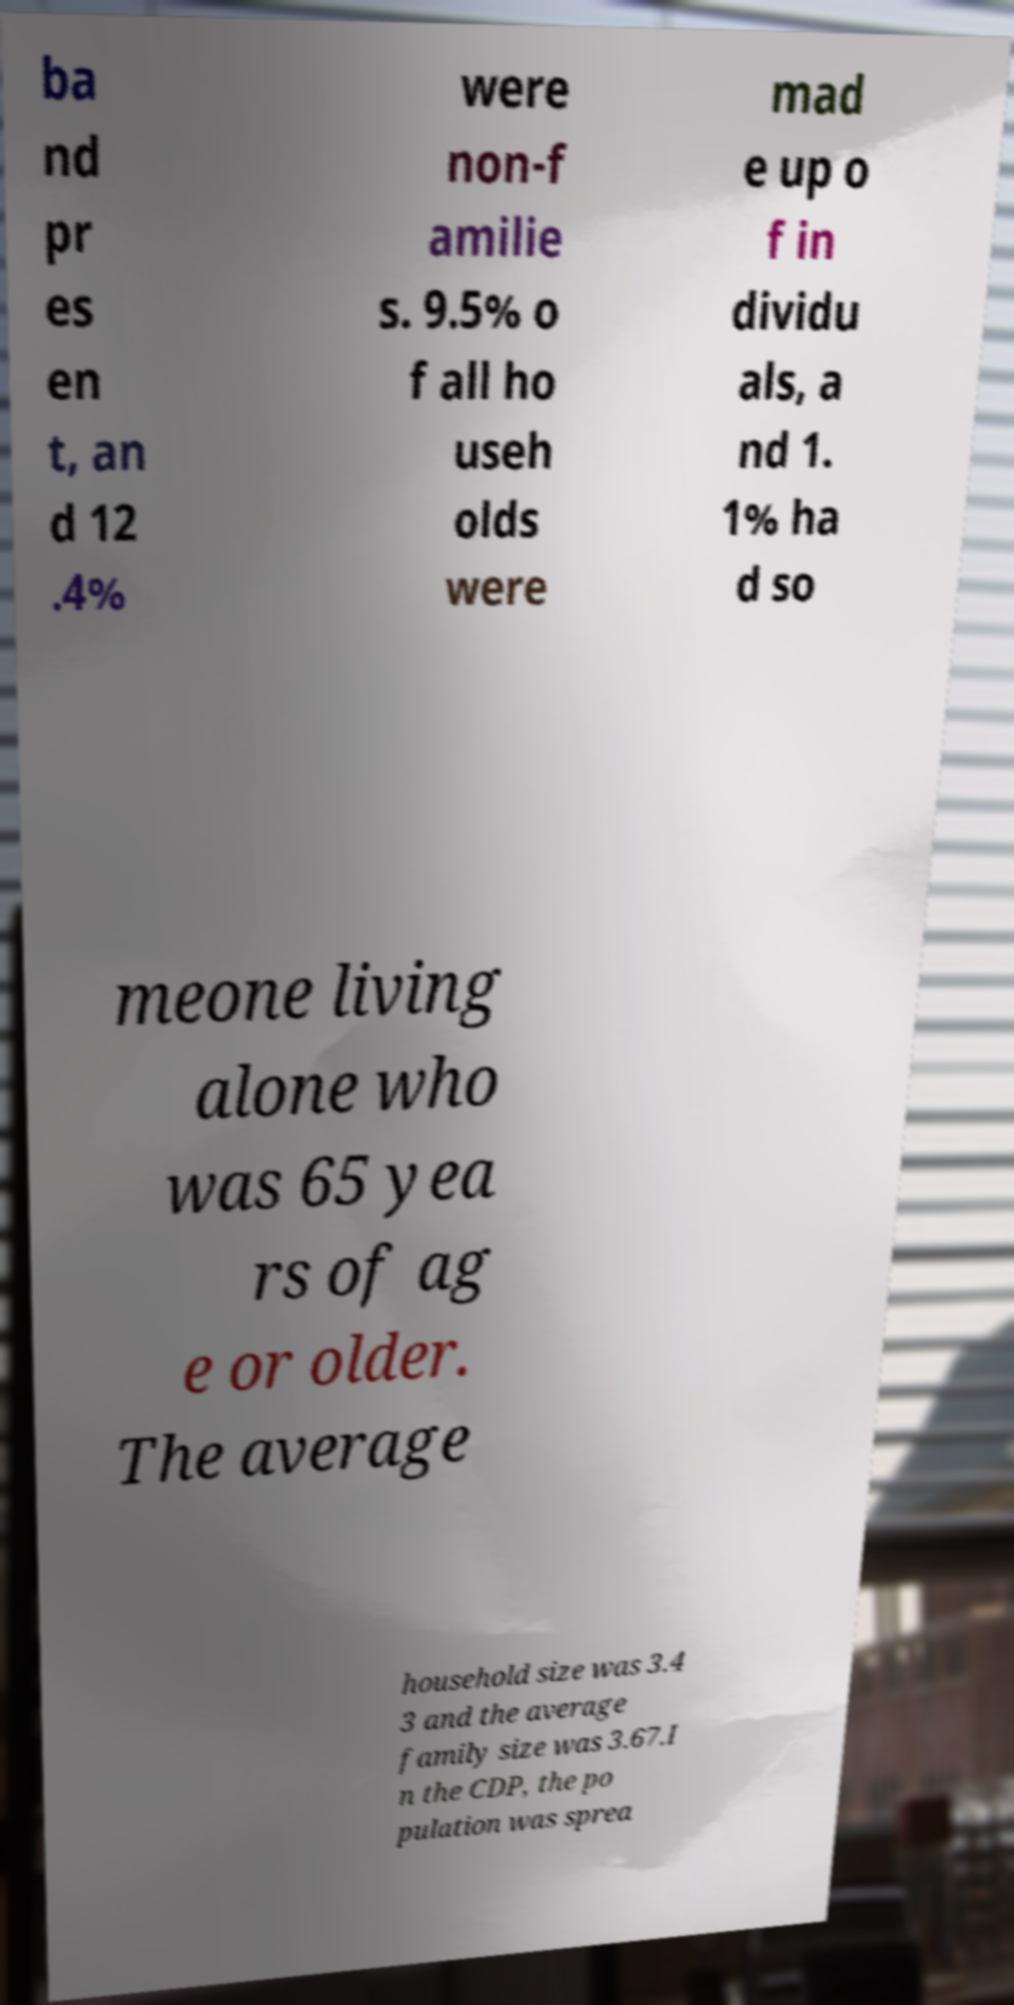What messages or text are displayed in this image? I need them in a readable, typed format. ba nd pr es en t, an d 12 .4% were non-f amilie s. 9.5% o f all ho useh olds were mad e up o f in dividu als, a nd 1. 1% ha d so meone living alone who was 65 yea rs of ag e or older. The average household size was 3.4 3 and the average family size was 3.67.I n the CDP, the po pulation was sprea 